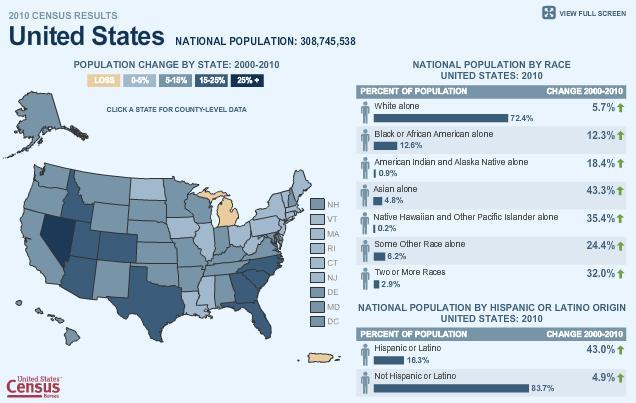What is the percentage of white and Asian alone, taken together?
Answer the question with a short phrase. 77.2% What is the percentage of white and black alone, taken together? 85% 